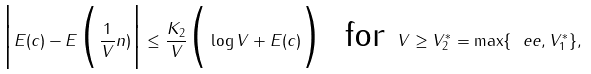Convert formula to latex. <formula><loc_0><loc_0><loc_500><loc_500>\Big | E ( c ) - E \Big ( \frac { 1 } { V } n ) \Big | \leq \frac { K _ { 2 } } V \Big ( \log V + E ( c ) \Big ) \ \text { for } V \geq V ^ { * } _ { 2 } = \max \{ \ e e , V ^ { * } _ { 1 } \} ,</formula> 